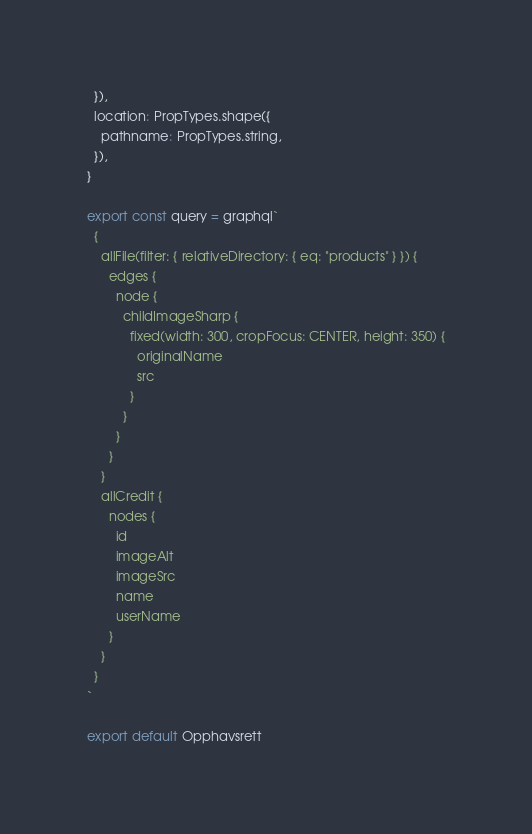Convert code to text. <code><loc_0><loc_0><loc_500><loc_500><_JavaScript_>  }),
  location: PropTypes.shape({
    pathname: PropTypes.string,
  }),
}

export const query = graphql`
  {
    allFile(filter: { relativeDirectory: { eq: "products" } }) {
      edges {
        node {
          childImageSharp {
            fixed(width: 300, cropFocus: CENTER, height: 350) {
              originalName
              src
            }
          }
        }
      }
    }
    allCredit {
      nodes {
        id
        imageAlt
        imageSrc
        name
        userName
      }
    }
  }
`

export default Opphavsrett
</code> 